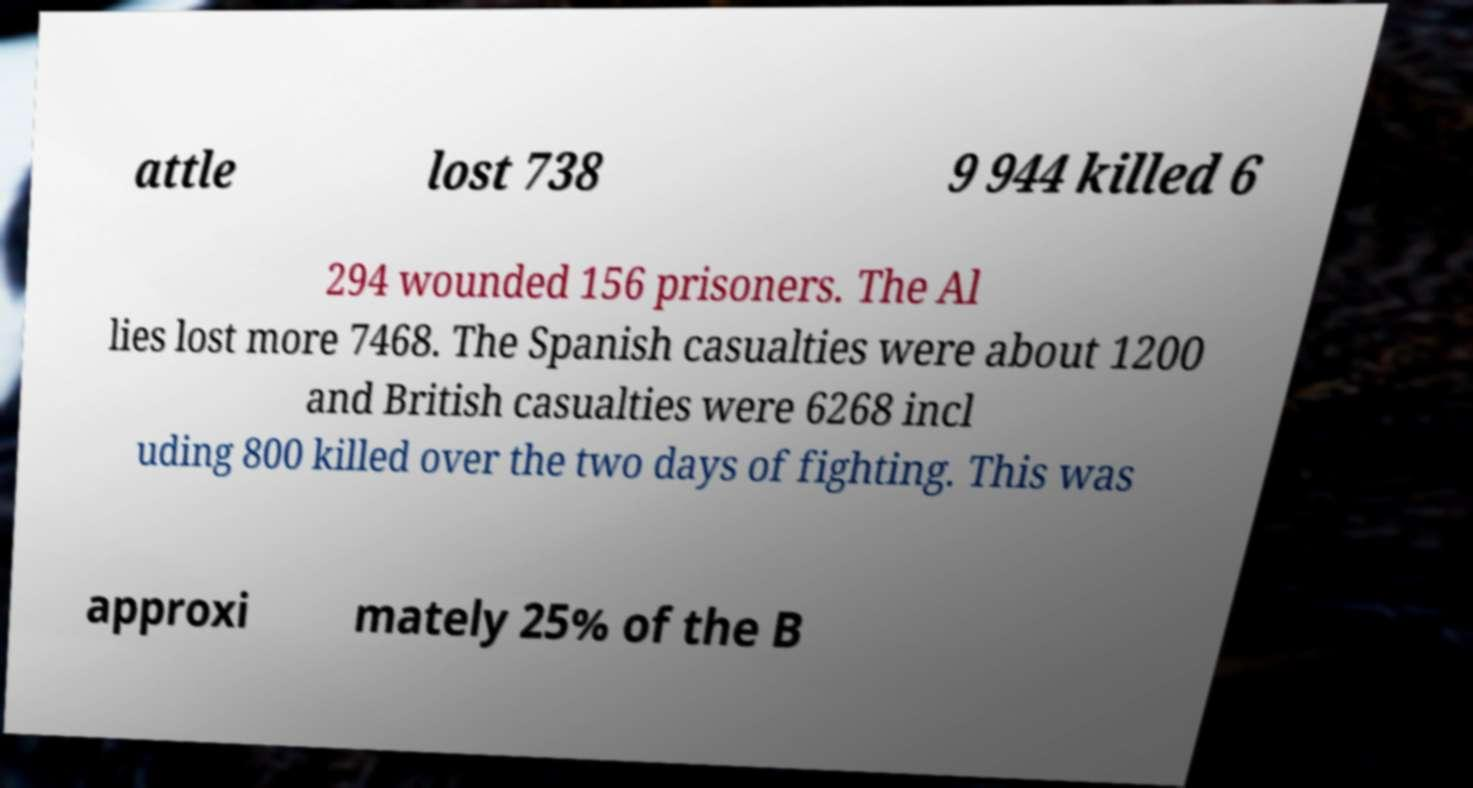Can you accurately transcribe the text from the provided image for me? attle lost 738 9 944 killed 6 294 wounded 156 prisoners. The Al lies lost more 7468. The Spanish casualties were about 1200 and British casualties were 6268 incl uding 800 killed over the two days of fighting. This was approxi mately 25% of the B 